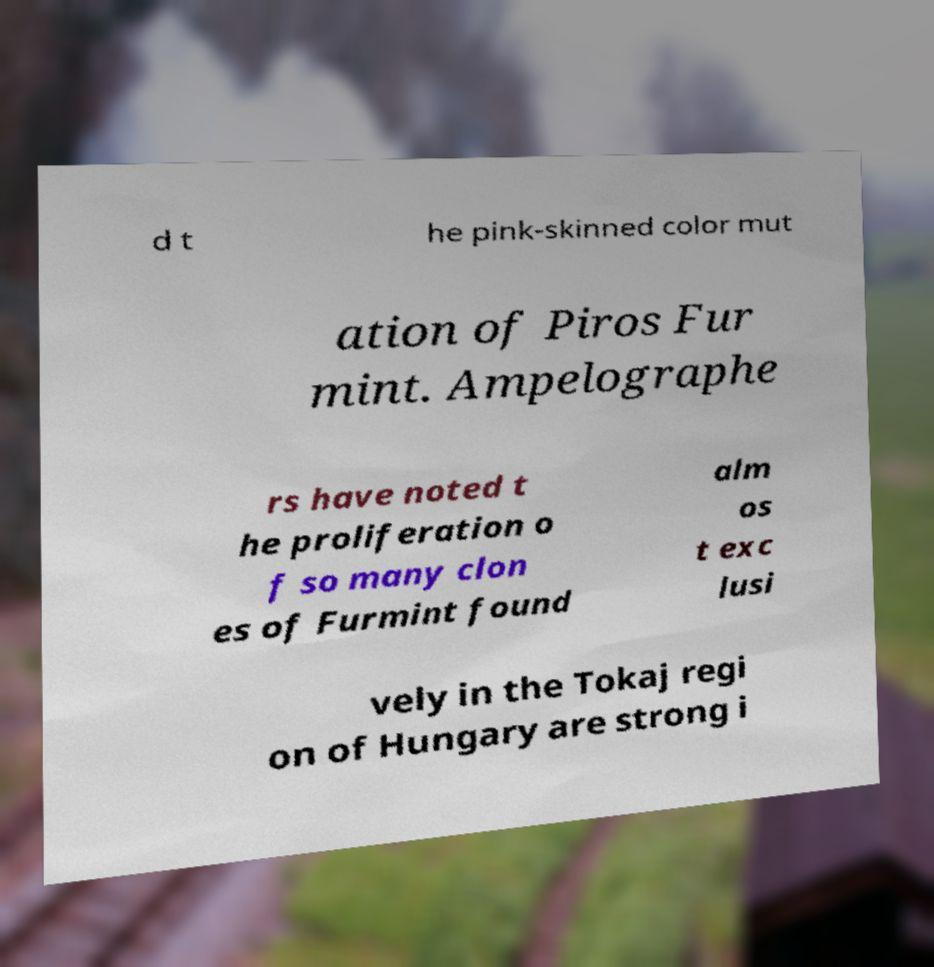Can you accurately transcribe the text from the provided image for me? d t he pink-skinned color mut ation of Piros Fur mint. Ampelographe rs have noted t he proliferation o f so many clon es of Furmint found alm os t exc lusi vely in the Tokaj regi on of Hungary are strong i 